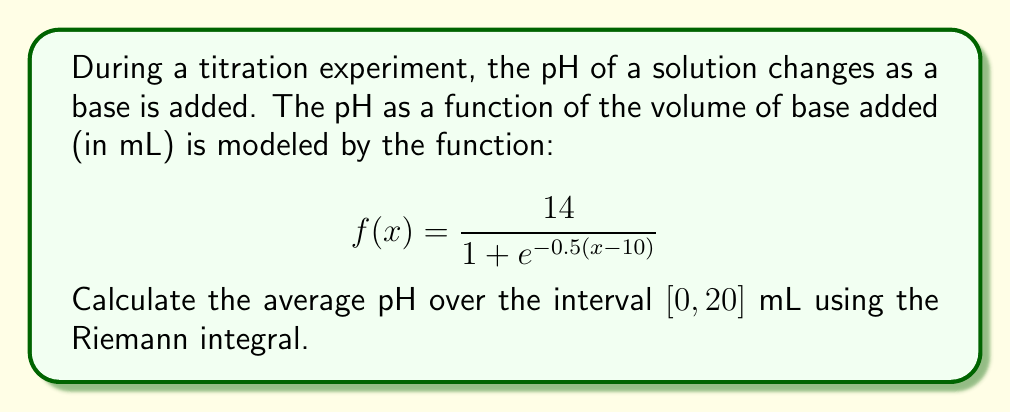Show me your answer to this math problem. To find the average pH over the interval $[0, 20]$ mL, we need to:

1. Calculate the Riemann integral of $f(x)$ over $[0, 20]$.
2. Divide the result by the length of the interval.

Step 1: Calculate the Riemann integral

The Riemann integral is given by:

$$\int_0^{20} f(x) dx = \int_0^{20} \frac{14}{1 + e^{-0.5(x-10)}} dx$$

This integral doesn't have an elementary antiderivative, so we need to use a substitution method:

Let $u = e^{-0.5(x-10)}$, then $du = -0.5e^{-0.5(x-10)} dx$, or $dx = -2du/u$

When $x = 0$, $u = e^5$
When $x = 20$, $u = e^{-5}$

Substituting:

$$\int_0^{20} \frac{14}{1 + e^{-0.5(x-10)}} dx = -28 \int_{e^5}^{e^{-5}} \frac{1}{u(1+u)} du$$

Now we can use partial fractions:

$$\frac{1}{u(1+u)} = \frac{1}{u} - \frac{1}{1+u}$$

So our integral becomes:

$$-28 \int_{e^5}^{e^{-5}} (\frac{1}{u} - \frac{1}{1+u}) du = -28 [\ln|u| - \ln|1+u|]_{e^5}^{e^{-5}}$$

$$= -28 [(-5 - \ln(1+e^{-5})) - (5 - \ln(1+e^5))]$$
$$= -28 [-10 - \ln(1+e^{-5}) + \ln(1+e^5)]$$
$$\approx 280.07$$

Step 2: Divide by the length of the interval

The length of the interval is $20 - 0 = 20$ mL.

Average pH = $280.07 / 20 \approx 14.00$
Answer: The average pH over the interval $[0, 20]$ mL is approximately 14.00. 